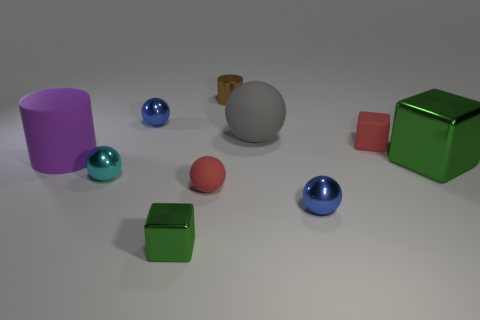Can you describe the colors and textures of the objects in the scene? The scene includes a variety of colors and textures. The purple rubber cylinder has a matte finish, the blue and pink metal spheres exhibit a glossy texture, and the green and lighter green boxes showcase a slightly reflective surface. The red object appears to be a smaller cube with a similar matte finish to the cylinder. 